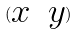Convert formula to latex. <formula><loc_0><loc_0><loc_500><loc_500>( \begin{matrix} x & y \end{matrix} )</formula> 